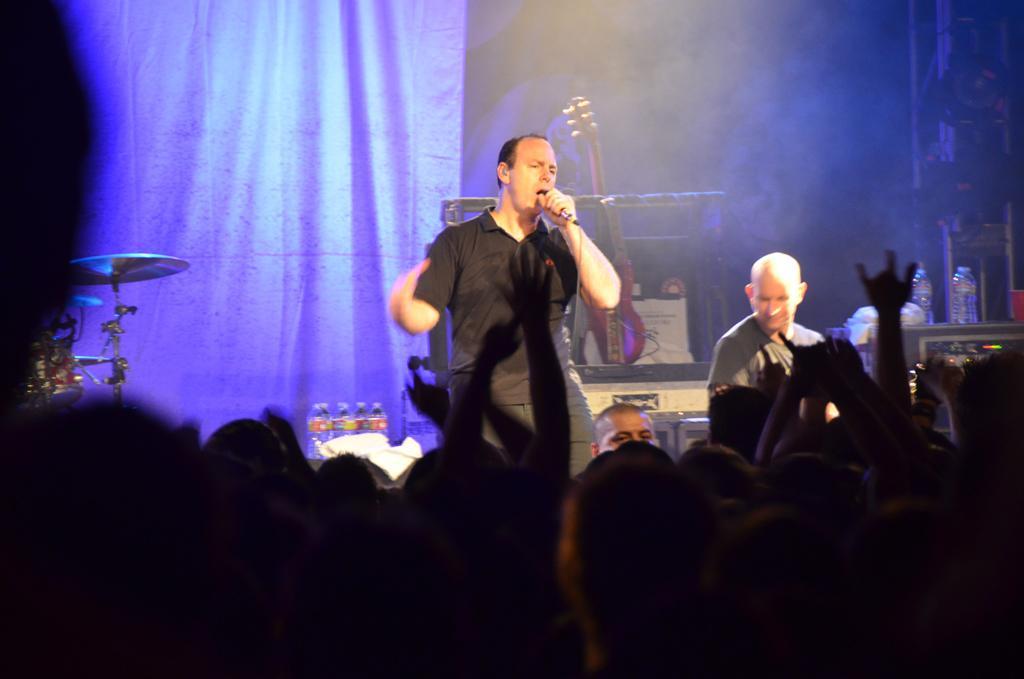Could you give a brief overview of what you see in this image? Here in this picture in the middle we can see a person singing a song with a microphone in his hands, beside him also we can see another person present and behind them we can see musical instruments present over there and we can also see water bottles present and in the front we can see number of people standing and watching them and behind them we can see a curtain present. 